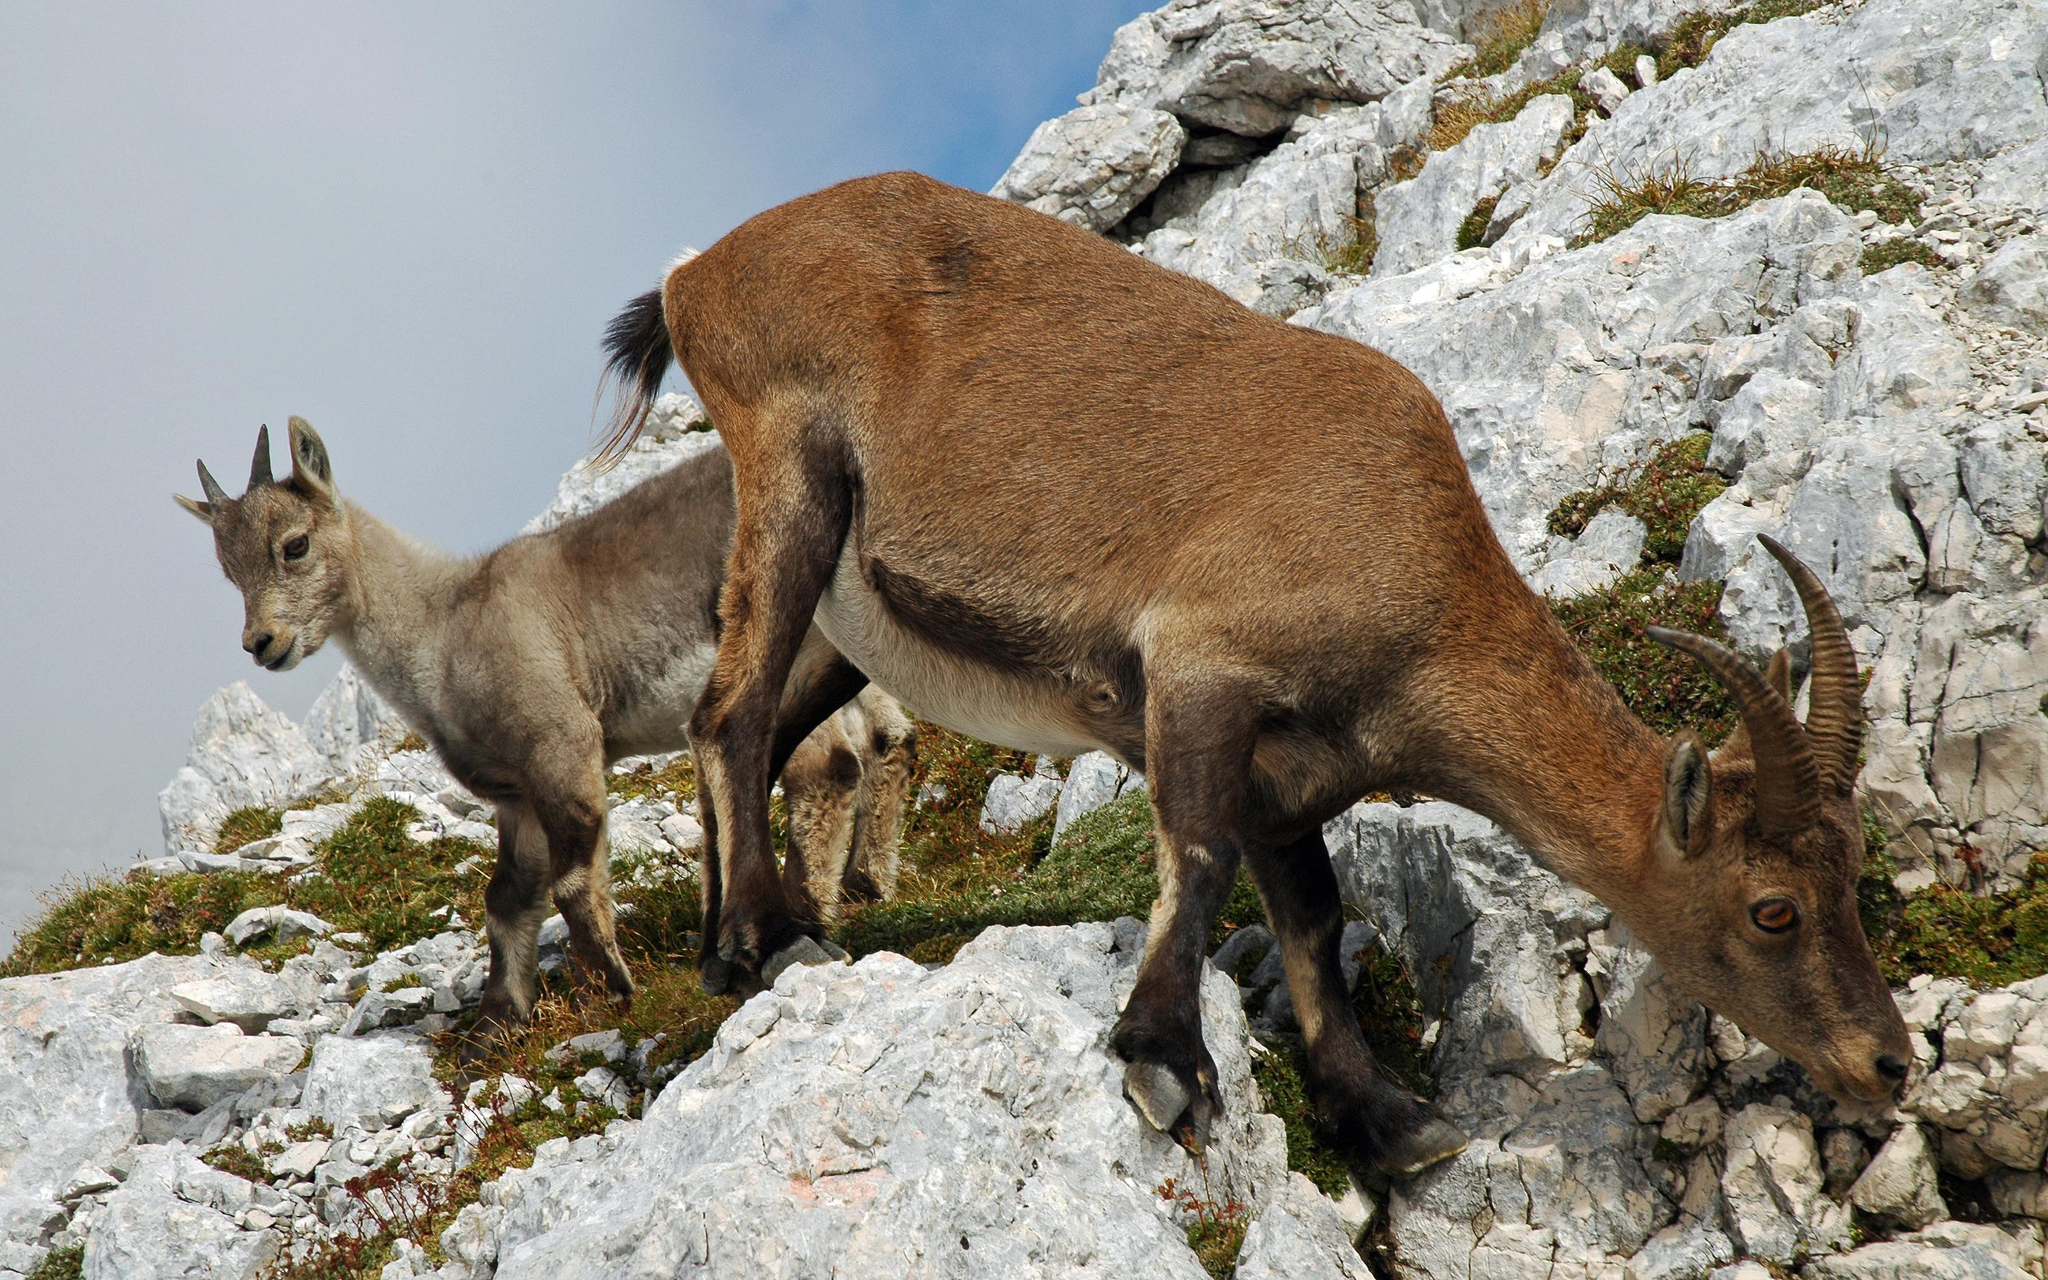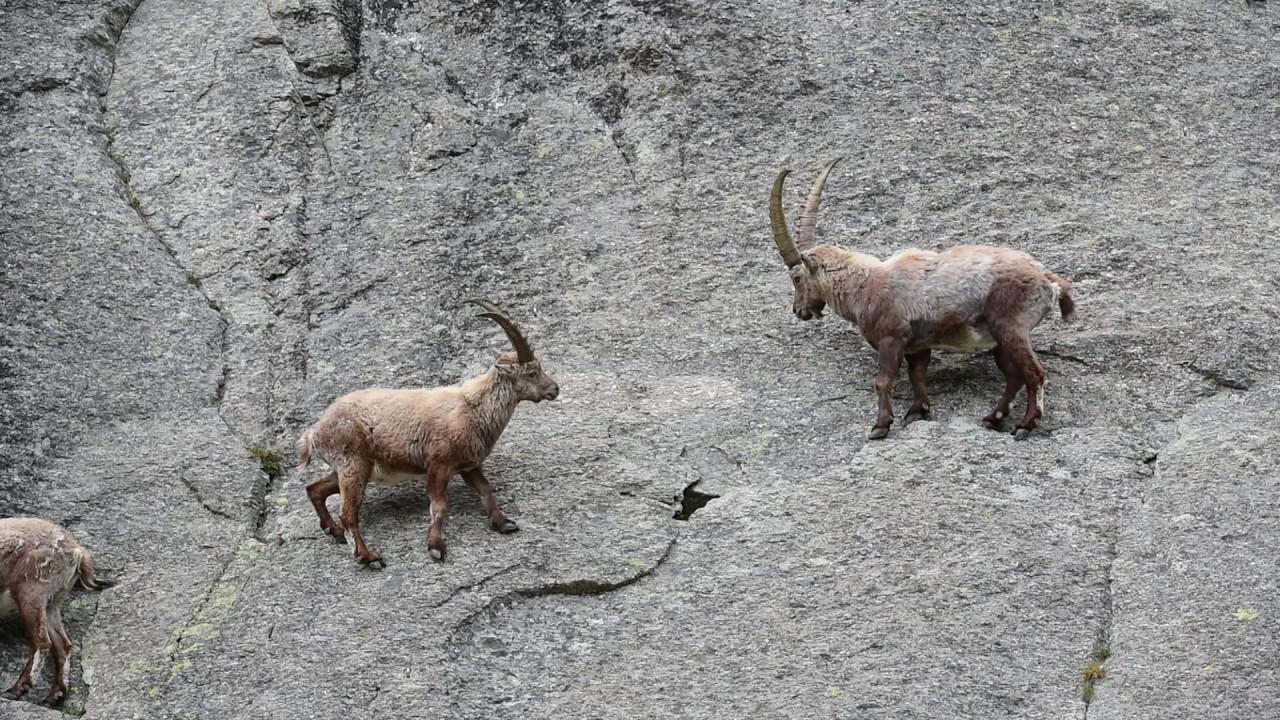The first image is the image on the left, the second image is the image on the right. For the images shown, is this caption "Left image shows exactly one horned animal, with both horns showing clearly and separately." true? Answer yes or no. No. The first image is the image on the left, the second image is the image on the right. Evaluate the accuracy of this statement regarding the images: "the animals in the image on the right are on a steep hillside.". Is it true? Answer yes or no. Yes. 